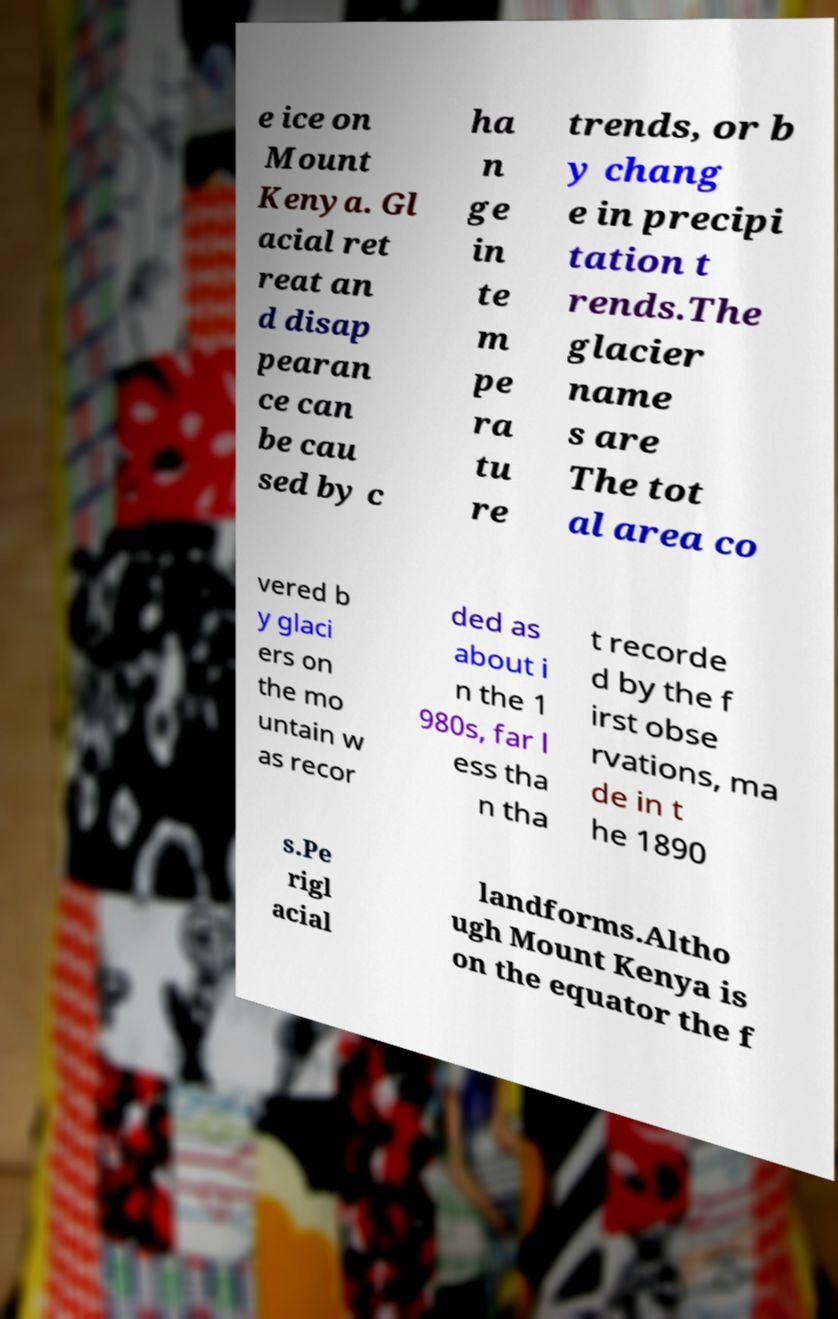Could you extract and type out the text from this image? e ice on Mount Kenya. Gl acial ret reat an d disap pearan ce can be cau sed by c ha n ge in te m pe ra tu re trends, or b y chang e in precipi tation t rends.The glacier name s are The tot al area co vered b y glaci ers on the mo untain w as recor ded as about i n the 1 980s, far l ess tha n tha t recorde d by the f irst obse rvations, ma de in t he 1890 s.Pe rigl acial landforms.Altho ugh Mount Kenya is on the equator the f 